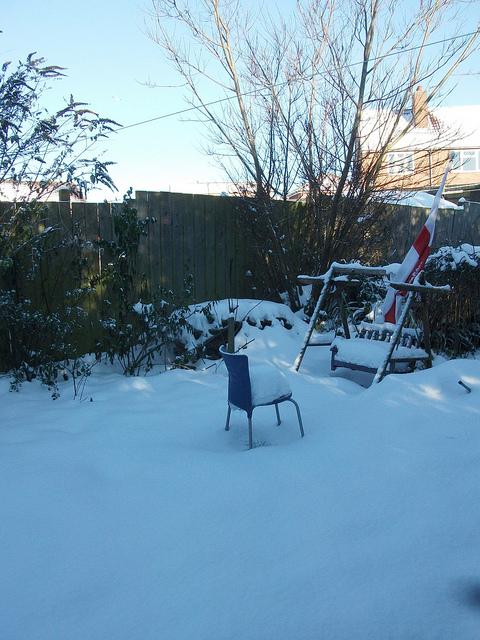What color is the sky in this picture?
Quick response, please. Blue. Is there a snow storm?
Answer briefly. Yes. What is this person doing?
Concise answer only. Nothing. Is the sun setting?
Be succinct. Yes. How many posts in the nearest segment of fence?
Give a very brief answer. 1. Is it daytime?
Keep it brief. Yes. How many inches of snow are on the chair?
Be succinct. 8. Overcast or sunny?
Short answer required. Sunny. 